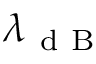Convert formula to latex. <formula><loc_0><loc_0><loc_500><loc_500>\lambda _ { d B }</formula> 